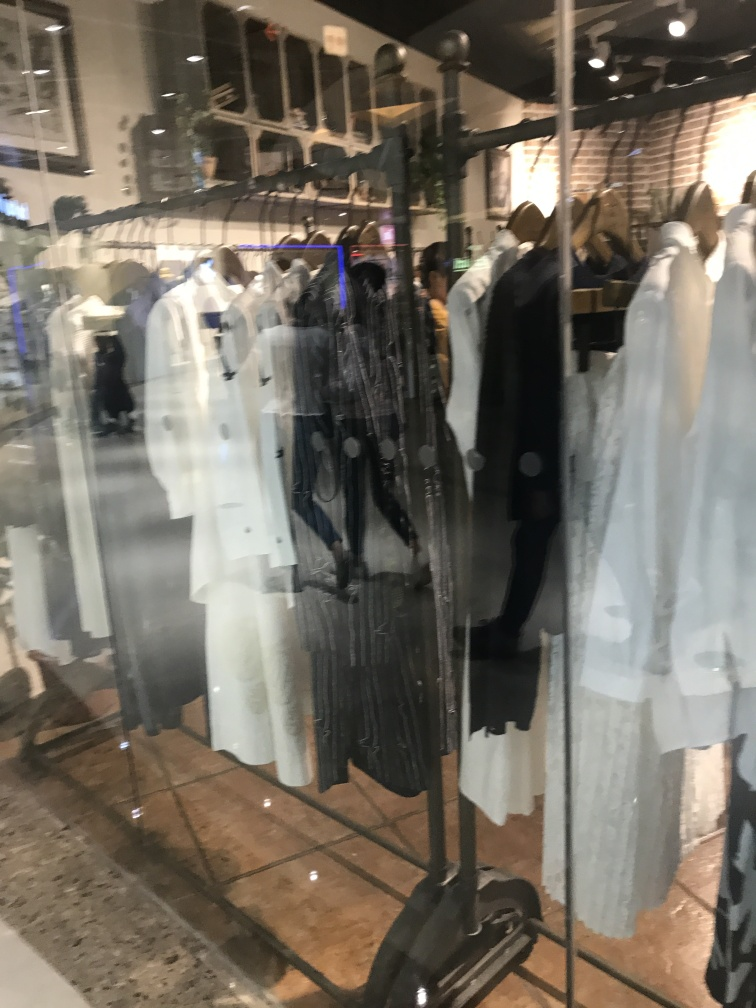Can you tell if there's a specific color scheme to the clothing collection shown here? Based on the image, the clothing collection features a neutral and monochrome color palette with shades of white, black, and grey. This creates a sophisticated and versatile array of options likely intended to appeal to shoppers looking for pieces that can be easily mixed and matched. Is there anything unusual or particularly striking about the way these clothes are presented? The clothing presentation is quite standard for a retail setting, with clothing arranged on racks and hung for clear visibility. However, the reflection on the glass in the foreground adds a layer of visual interest and may suggest that the photo was taken from outside the store, capturing both the interior arrangement and the dynamic reflections that overlap the clothing items. 